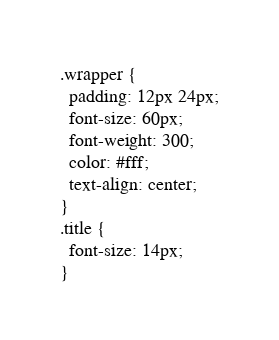Convert code to text. <code><loc_0><loc_0><loc_500><loc_500><_CSS_>.wrapper {
  padding: 12px 24px;
  font-size: 60px;
  font-weight: 300;
  color: #fff;
  text-align: center;
}
.title {
  font-size: 14px;
}


</code> 